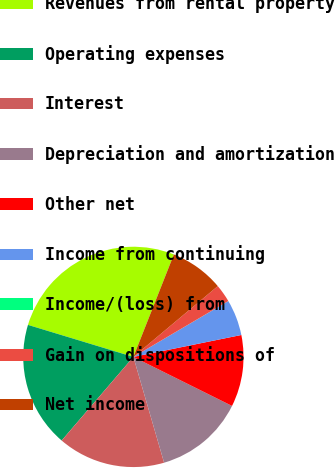Convert chart. <chart><loc_0><loc_0><loc_500><loc_500><pie_chart><fcel>Revenues from rental property<fcel>Operating expenses<fcel>Interest<fcel>Depreciation and amortization<fcel>Other net<fcel>Income from continuing<fcel>Income/(loss) from<fcel>Gain on dispositions of<fcel>Net income<nl><fcel>26.3%<fcel>18.41%<fcel>15.78%<fcel>13.16%<fcel>10.53%<fcel>5.27%<fcel>0.01%<fcel>2.64%<fcel>7.9%<nl></chart> 